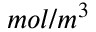Convert formula to latex. <formula><loc_0><loc_0><loc_500><loc_500>m o l / m ^ { 3 }</formula> 